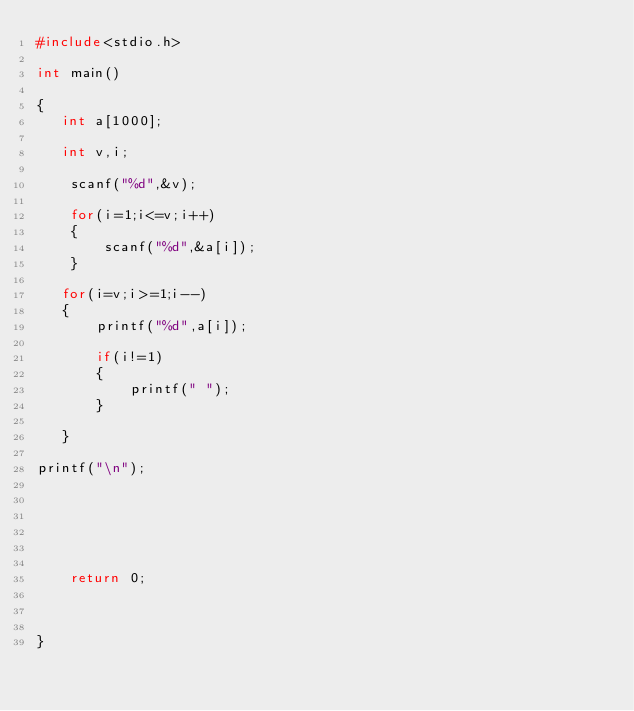<code> <loc_0><loc_0><loc_500><loc_500><_C_>#include<stdio.h>

int main()

{
   int a[1000];

   int v,i;

    scanf("%d",&v);

    for(i=1;i<=v;i++)
    {
        scanf("%d",&a[i]);
    }

   for(i=v;i>=1;i--)
   {
       printf("%d",a[i]);

       if(i!=1)
       {
           printf(" ");
       }

   }

printf("\n");






    return 0;



}

</code> 